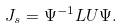Convert formula to latex. <formula><loc_0><loc_0><loc_500><loc_500>J _ { s } = \Psi ^ { - 1 } L U \Psi .</formula> 